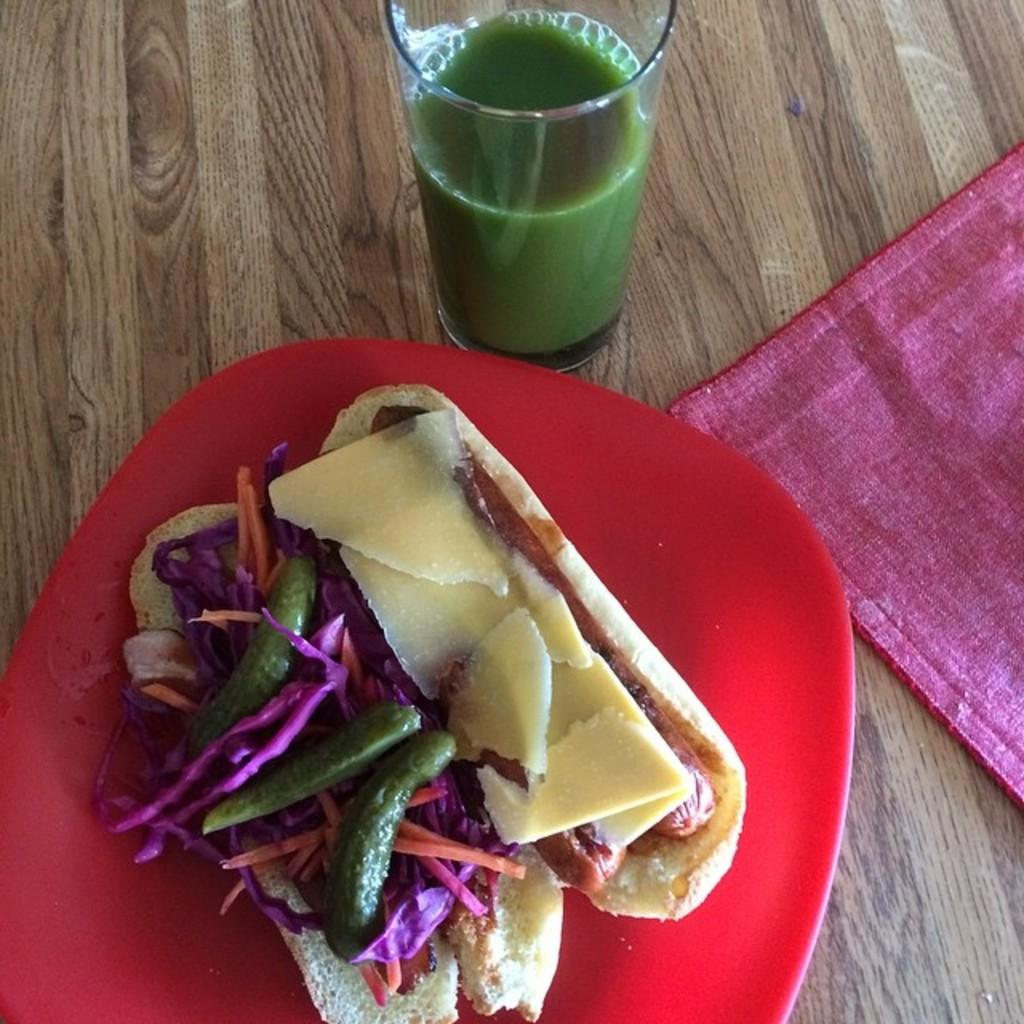What is the color of the plate that holds the food item in the image? The plate is red. What can be used for cleaning or wiping in the image? There is a napkin in the image. What type of beverage is in the glass in the image? There is a glass of green juice in the image. Where is the gate located in the image? There is no gate present in the image. What type of sponge is used for cleaning in the image? There is no sponge present in the image. 